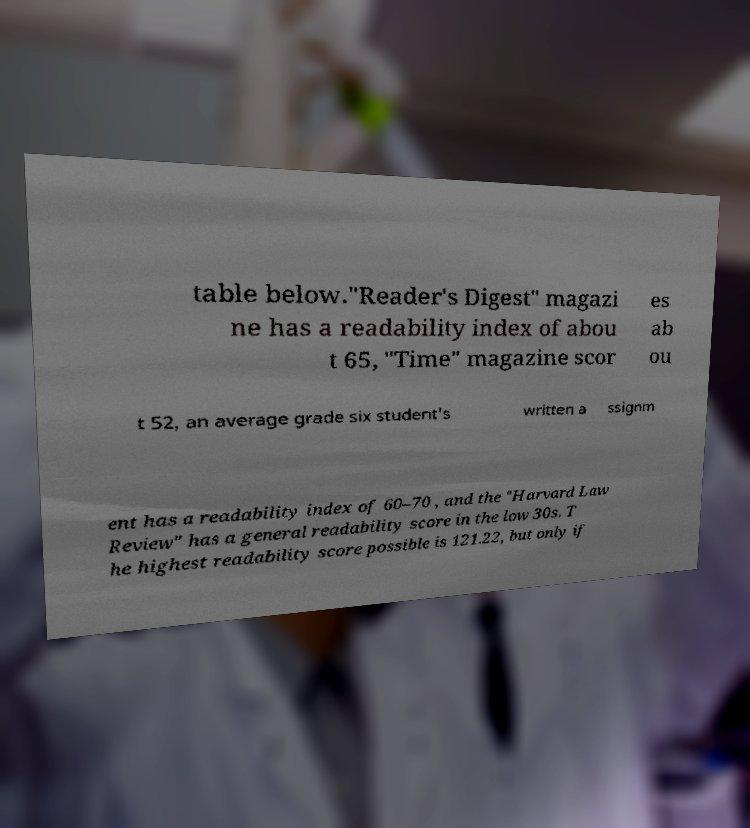Please identify and transcribe the text found in this image. table below."Reader's Digest" magazi ne has a readability index of abou t 65, "Time" magazine scor es ab ou t 52, an average grade six student's written a ssignm ent has a readability index of 60–70 , and the "Harvard Law Review" has a general readability score in the low 30s. T he highest readability score possible is 121.22, but only if 